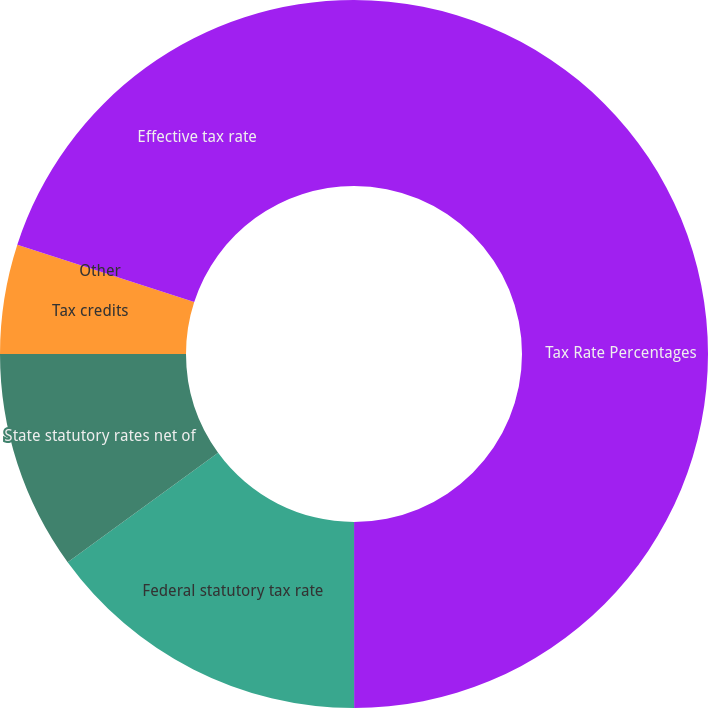Convert chart. <chart><loc_0><loc_0><loc_500><loc_500><pie_chart><fcel>Tax Rate Percentages<fcel>Federal statutory tax rate<fcel>State statutory rates net of<fcel>Tax credits<fcel>Other<fcel>Effective tax rate<nl><fcel>49.99%<fcel>15.0%<fcel>10.0%<fcel>5.0%<fcel>0.0%<fcel>20.0%<nl></chart> 